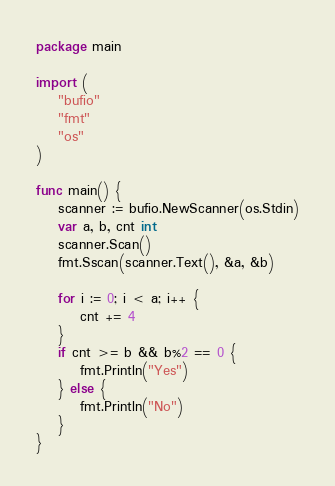Convert code to text. <code><loc_0><loc_0><loc_500><loc_500><_Go_>package main

import (
	"bufio"
	"fmt"
	"os"
)

func main() {
	scanner := bufio.NewScanner(os.Stdin)
	var a, b, cnt int
	scanner.Scan()
	fmt.Sscan(scanner.Text(), &a, &b)

	for i := 0; i < a; i++ {
		cnt += 4
	}
	if cnt >= b && b%2 == 0 {
		fmt.Println("Yes")
	} else {
		fmt.Println("No")
	}
}
</code> 